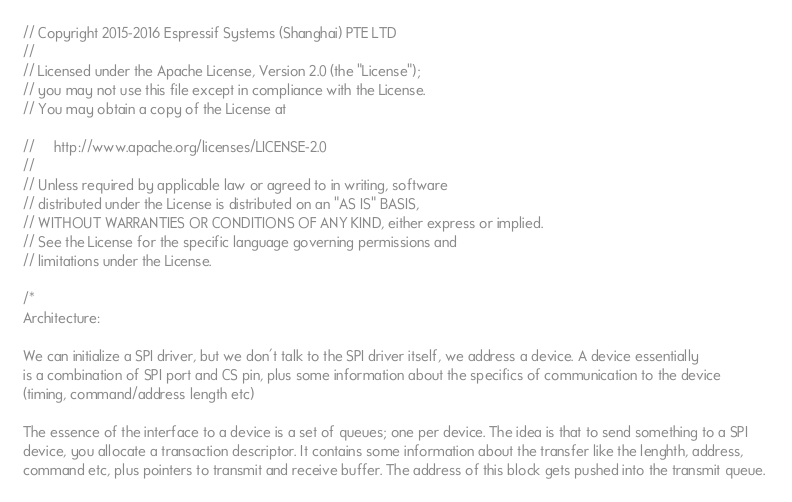<code> <loc_0><loc_0><loc_500><loc_500><_C_>// Copyright 2015-2016 Espressif Systems (Shanghai) PTE LTD
//
// Licensed under the Apache License, Version 2.0 (the "License");
// you may not use this file except in compliance with the License.
// You may obtain a copy of the License at

//     http://www.apache.org/licenses/LICENSE-2.0
//
// Unless required by applicable law or agreed to in writing, software
// distributed under the License is distributed on an "AS IS" BASIS,
// WITHOUT WARRANTIES OR CONDITIONS OF ANY KIND, either express or implied.
// See the License for the specific language governing permissions and
// limitations under the License.

/*
Architecture:

We can initialize a SPI driver, but we don't talk to the SPI driver itself, we address a device. A device essentially
is a combination of SPI port and CS pin, plus some information about the specifics of communication to the device
(timing, command/address length etc)

The essence of the interface to a device is a set of queues; one per device. The idea is that to send something to a SPI
device, you allocate a transaction descriptor. It contains some information about the transfer like the lenghth, address,
command etc, plus pointers to transmit and receive buffer. The address of this block gets pushed into the transmit queue. </code> 